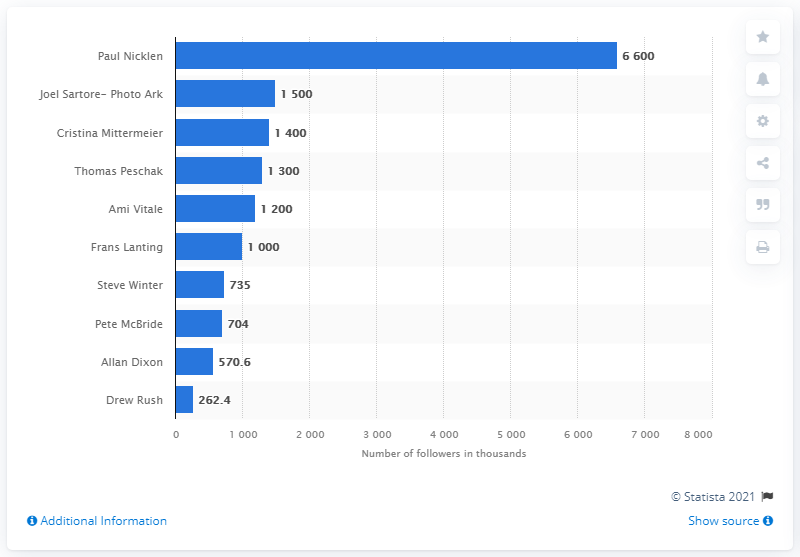Give some essential details in this illustration. Ami Vitale is a National Geographic photographer. 